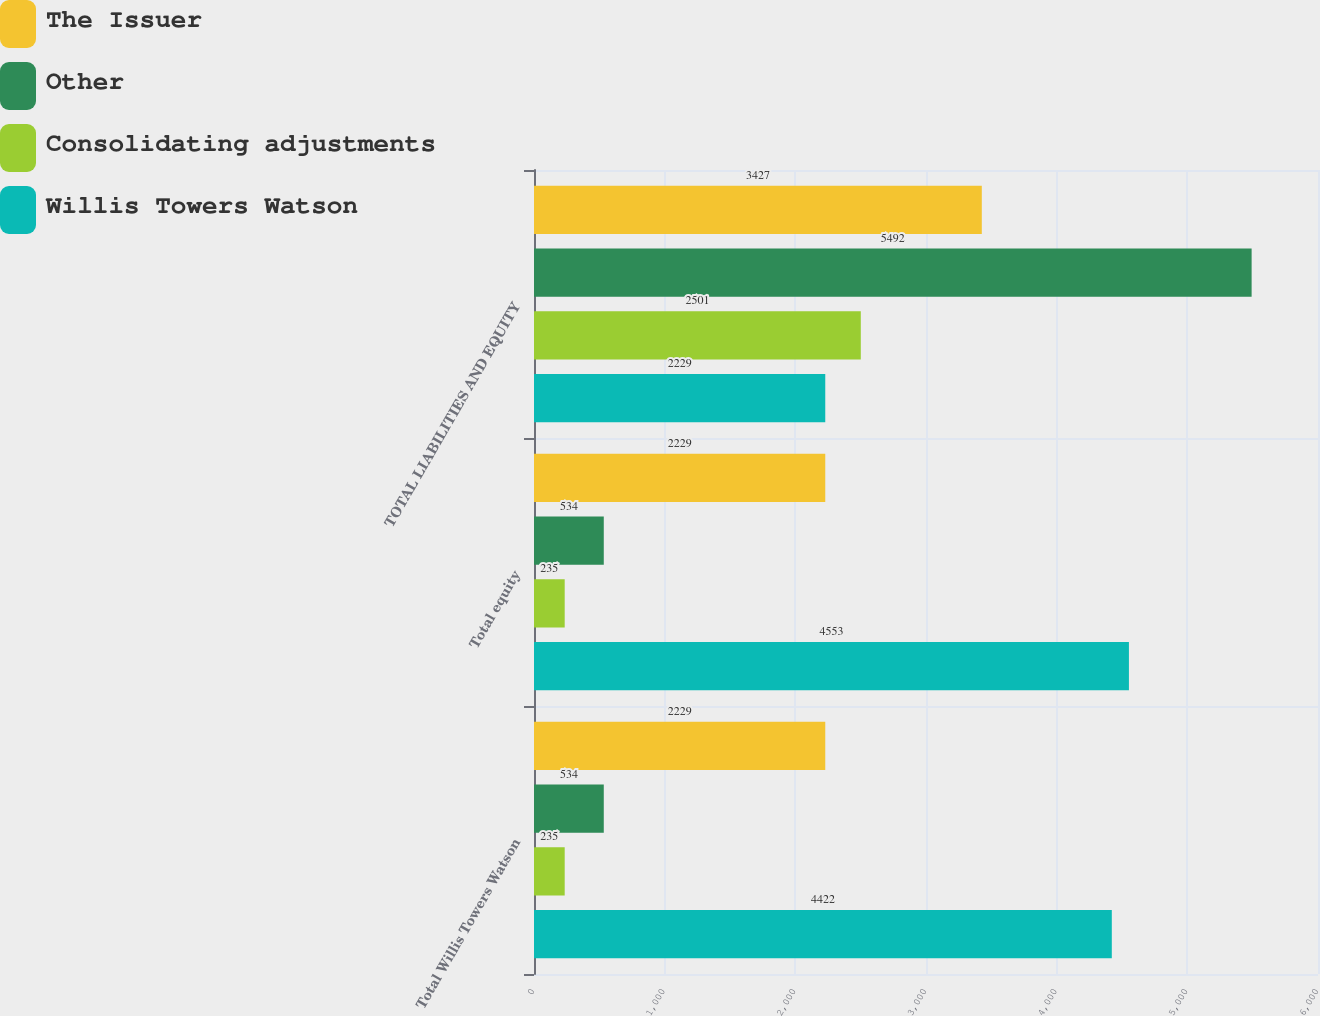<chart> <loc_0><loc_0><loc_500><loc_500><stacked_bar_chart><ecel><fcel>Total Willis Towers Watson<fcel>Total equity<fcel>TOTAL LIABILITIES AND EQUITY<nl><fcel>The Issuer<fcel>2229<fcel>2229<fcel>3427<nl><fcel>Other<fcel>534<fcel>534<fcel>5492<nl><fcel>Consolidating adjustments<fcel>235<fcel>235<fcel>2501<nl><fcel>Willis Towers Watson<fcel>4422<fcel>4553<fcel>2229<nl></chart> 